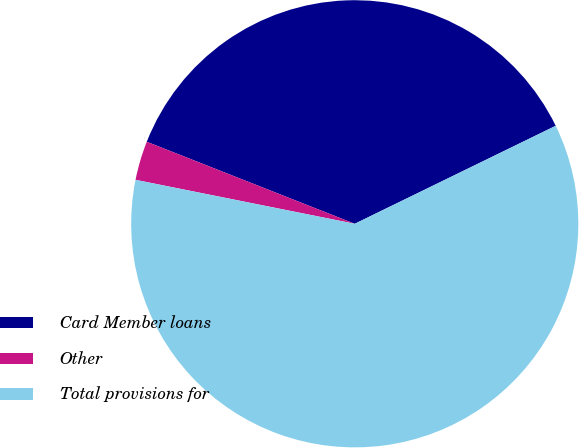Convert chart. <chart><loc_0><loc_0><loc_500><loc_500><pie_chart><fcel>Card Member loans<fcel>Other<fcel>Total provisions for<nl><fcel>36.8%<fcel>2.83%<fcel>60.37%<nl></chart> 